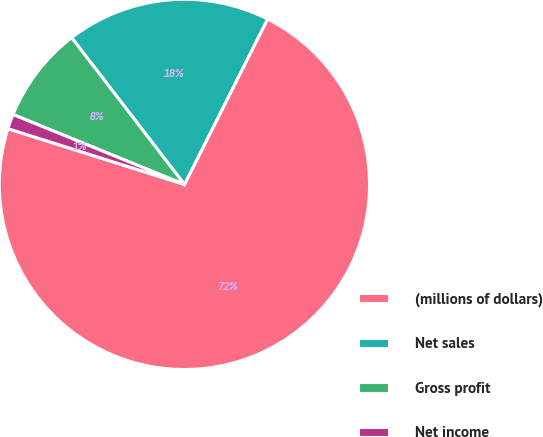Convert chart. <chart><loc_0><loc_0><loc_500><loc_500><pie_chart><fcel>(millions of dollars)<fcel>Net sales<fcel>Gross profit<fcel>Net income<nl><fcel>72.46%<fcel>17.84%<fcel>8.41%<fcel>1.29%<nl></chart> 